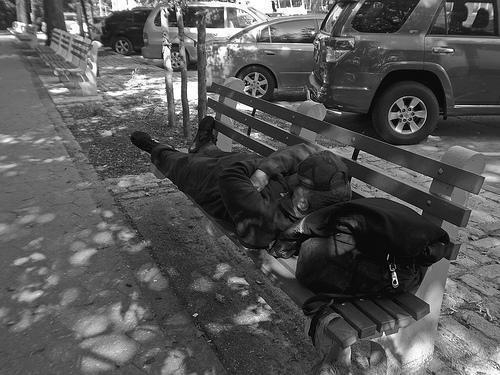How many cats are in the photo?
Give a very brief answer. 0. How many people are on the bench?
Give a very brief answer. 1. 